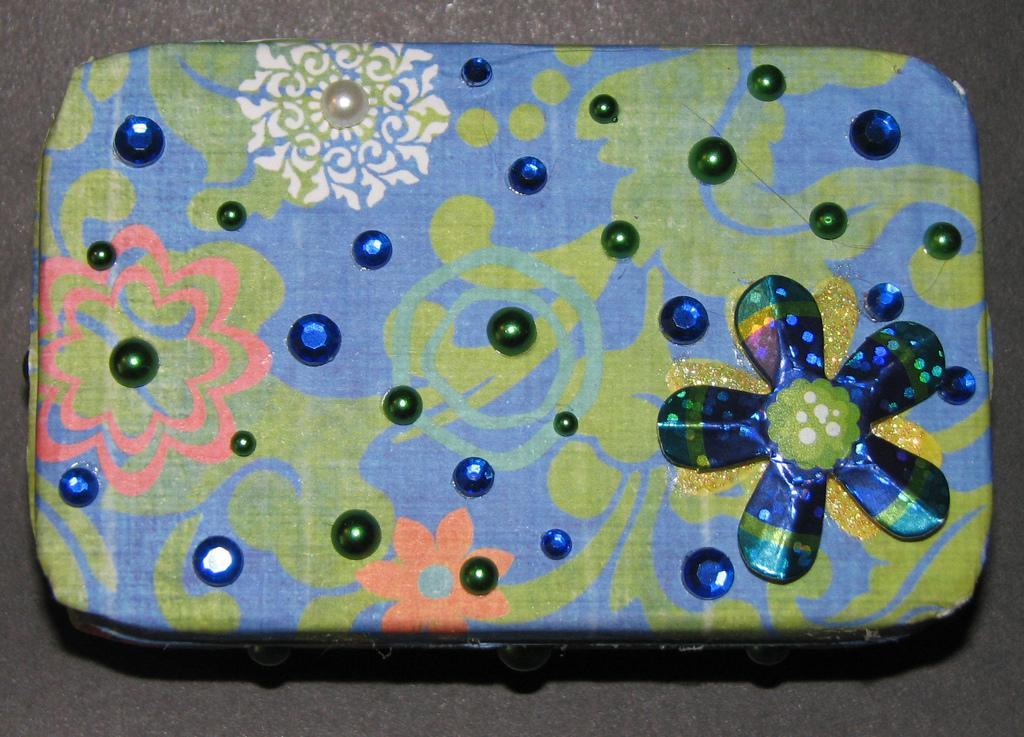Describe this image in one or two sentences. In this image we can see a box on which cloth is there and we can see some art on it which is placed on the black surface. 